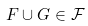<formula> <loc_0><loc_0><loc_500><loc_500>F \cup G \in { \mathcal { F } }</formula> 